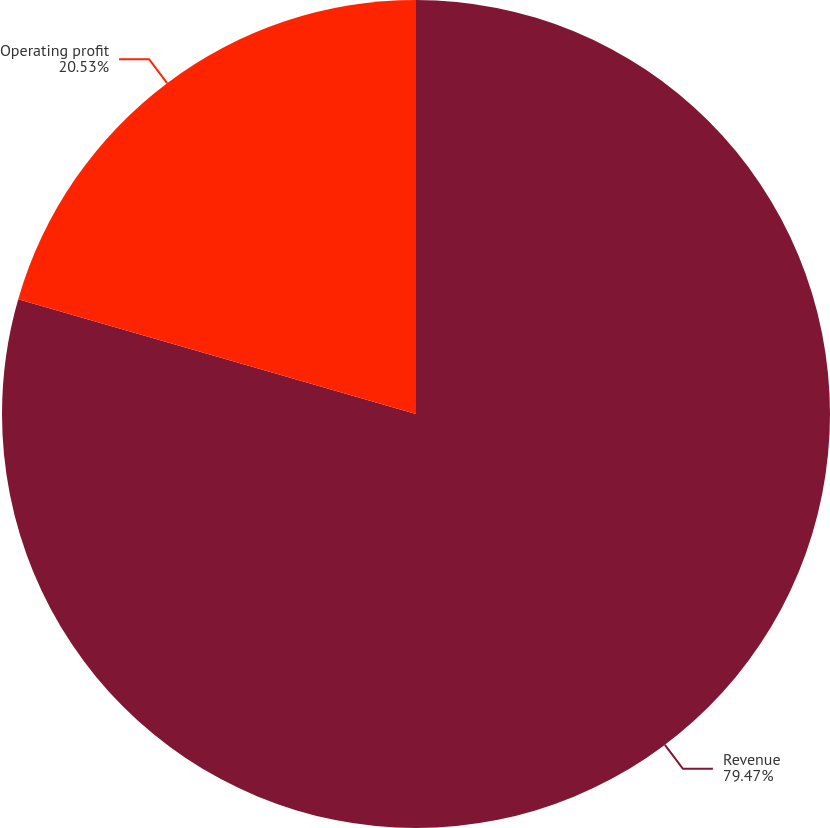Convert chart. <chart><loc_0><loc_0><loc_500><loc_500><pie_chart><fcel>Revenue<fcel>Operating profit<nl><fcel>79.47%<fcel>20.53%<nl></chart> 